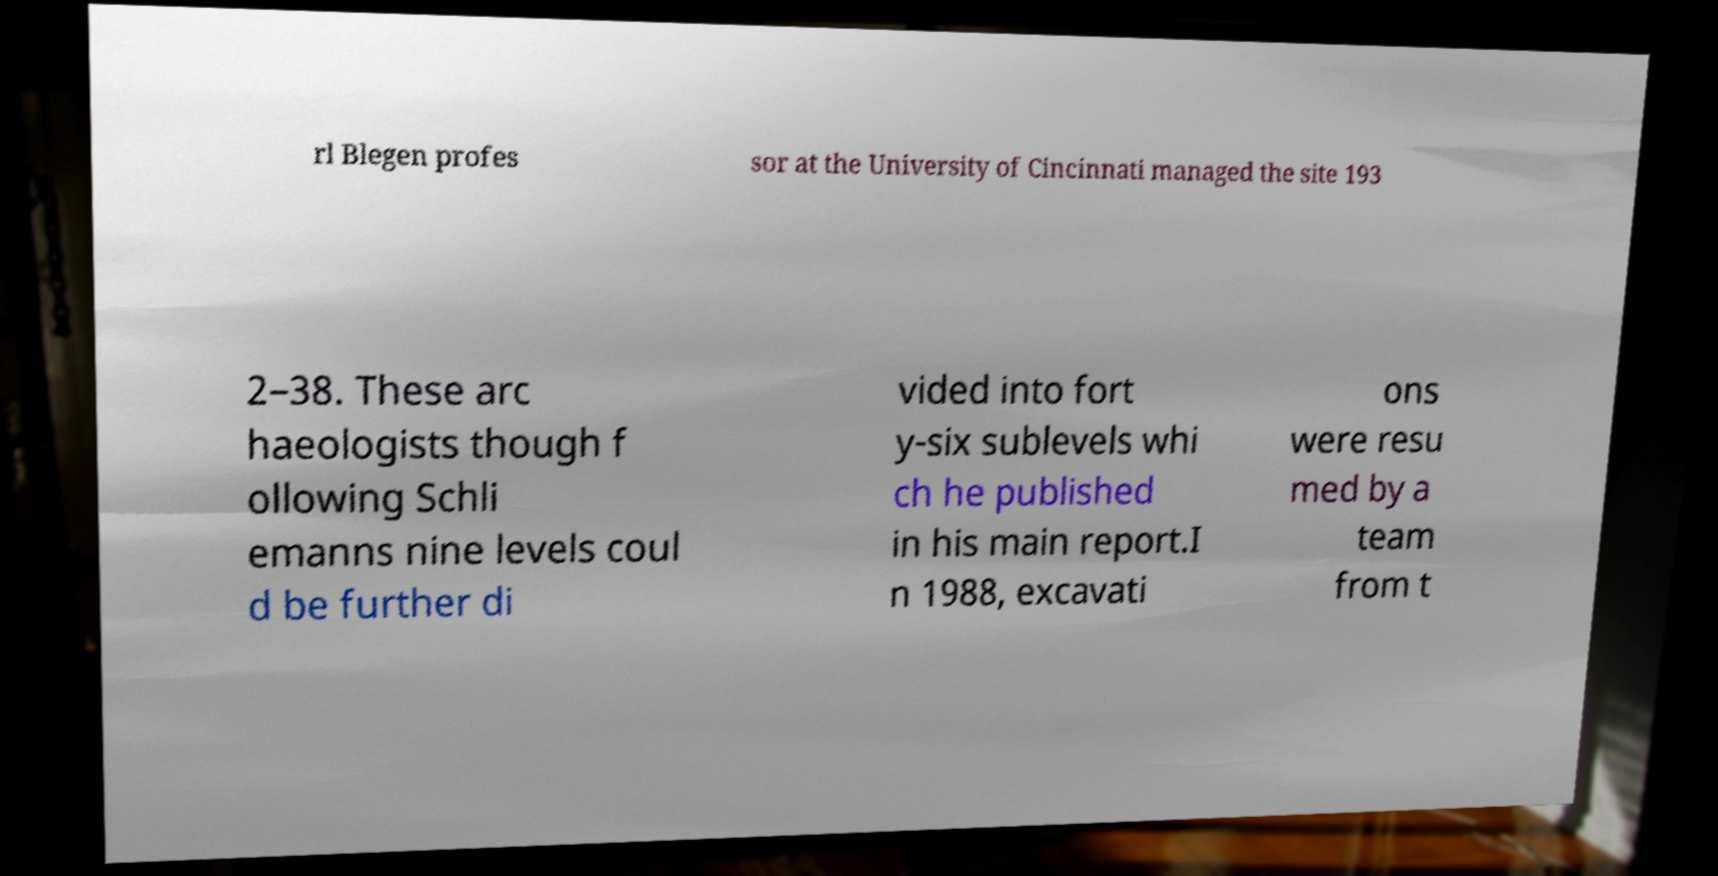Could you extract and type out the text from this image? rl Blegen profes sor at the University of Cincinnati managed the site 193 2–38. These arc haeologists though f ollowing Schli emanns nine levels coul d be further di vided into fort y-six sublevels whi ch he published in his main report.I n 1988, excavati ons were resu med by a team from t 